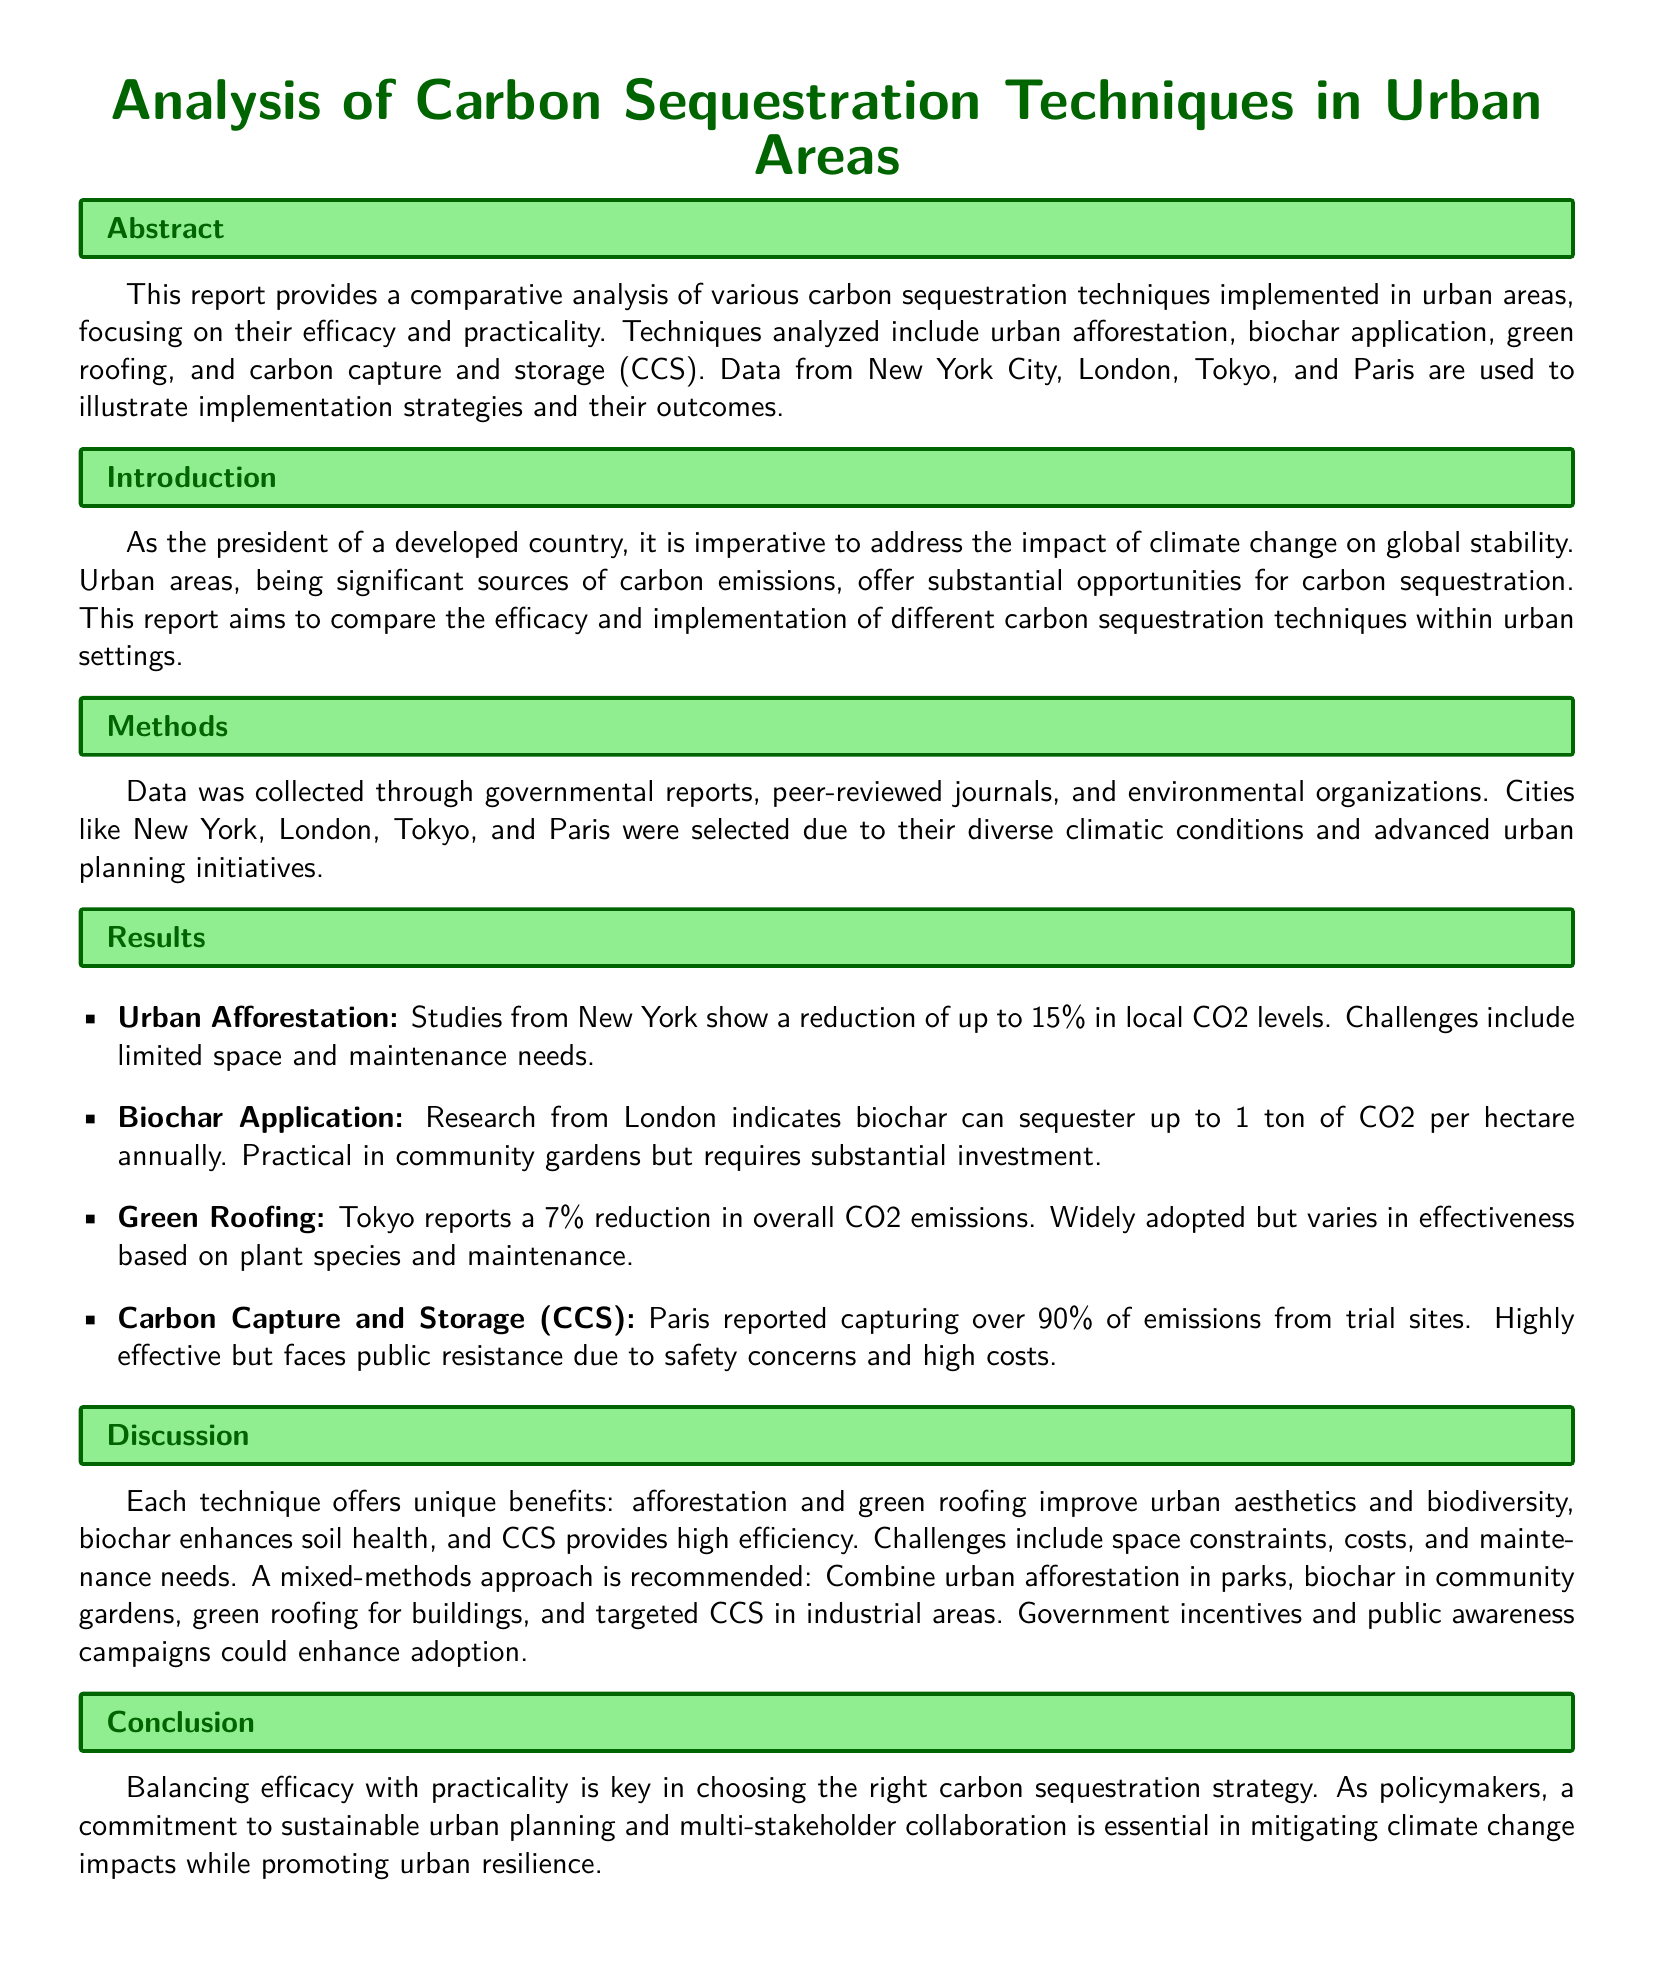what is the main focus of the report? The report focuses on comparing the efficacy and practicality of various carbon sequestration techniques implemented in urban areas.
Answer: comparing the efficacy and practicality of carbon sequestration techniques which city reported a 15% reduction in local CO2 levels? The report states that studies from New York show a reduction of up to 15% in local CO2 levels.
Answer: New York how much CO2 can biochar sequester per hectare annually? According to research from London, biochar can sequester up to 1 ton of CO2 per hectare annually.
Answer: 1 ton what is one benefit of urban afforestation mentioned in the report? The report mentions that urban afforestation improves urban aesthetics and biodiversity.
Answer: improves urban aesthetics and biodiversity what mixed-methods approach is recommended in the discussion? The report recommends combining urban afforestation in parks, biochar in community gardens, green roofing for buildings, and targeted CCS in industrial areas.
Answer: combining urban afforestation, biochar, green roofing, and targeted CCS which city captured over 90% of emissions from trial sites? Paris reported capturing over 90% of emissions from trial sites.
Answer: Paris what are two challenges mentioned for carbon capture and storage (CCS)? The report states that CCS faces public resistance due to safety concerns and high costs.
Answer: public resistance and high costs 